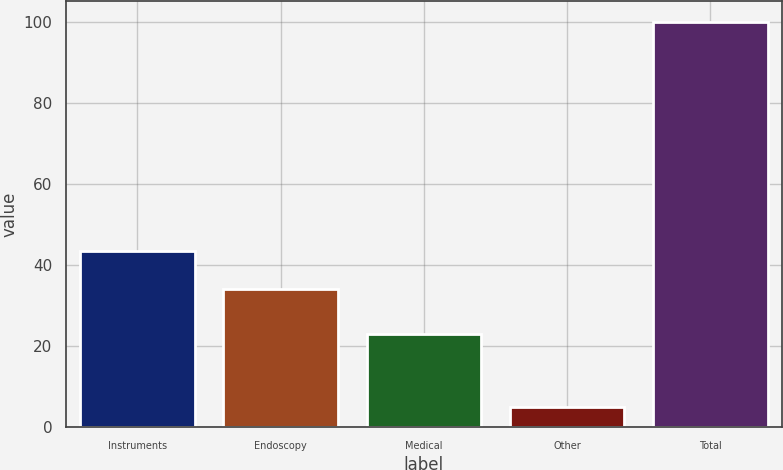<chart> <loc_0><loc_0><loc_500><loc_500><bar_chart><fcel>Instruments<fcel>Endoscopy<fcel>Medical<fcel>Other<fcel>Total<nl><fcel>43.5<fcel>34<fcel>23<fcel>5<fcel>100<nl></chart> 